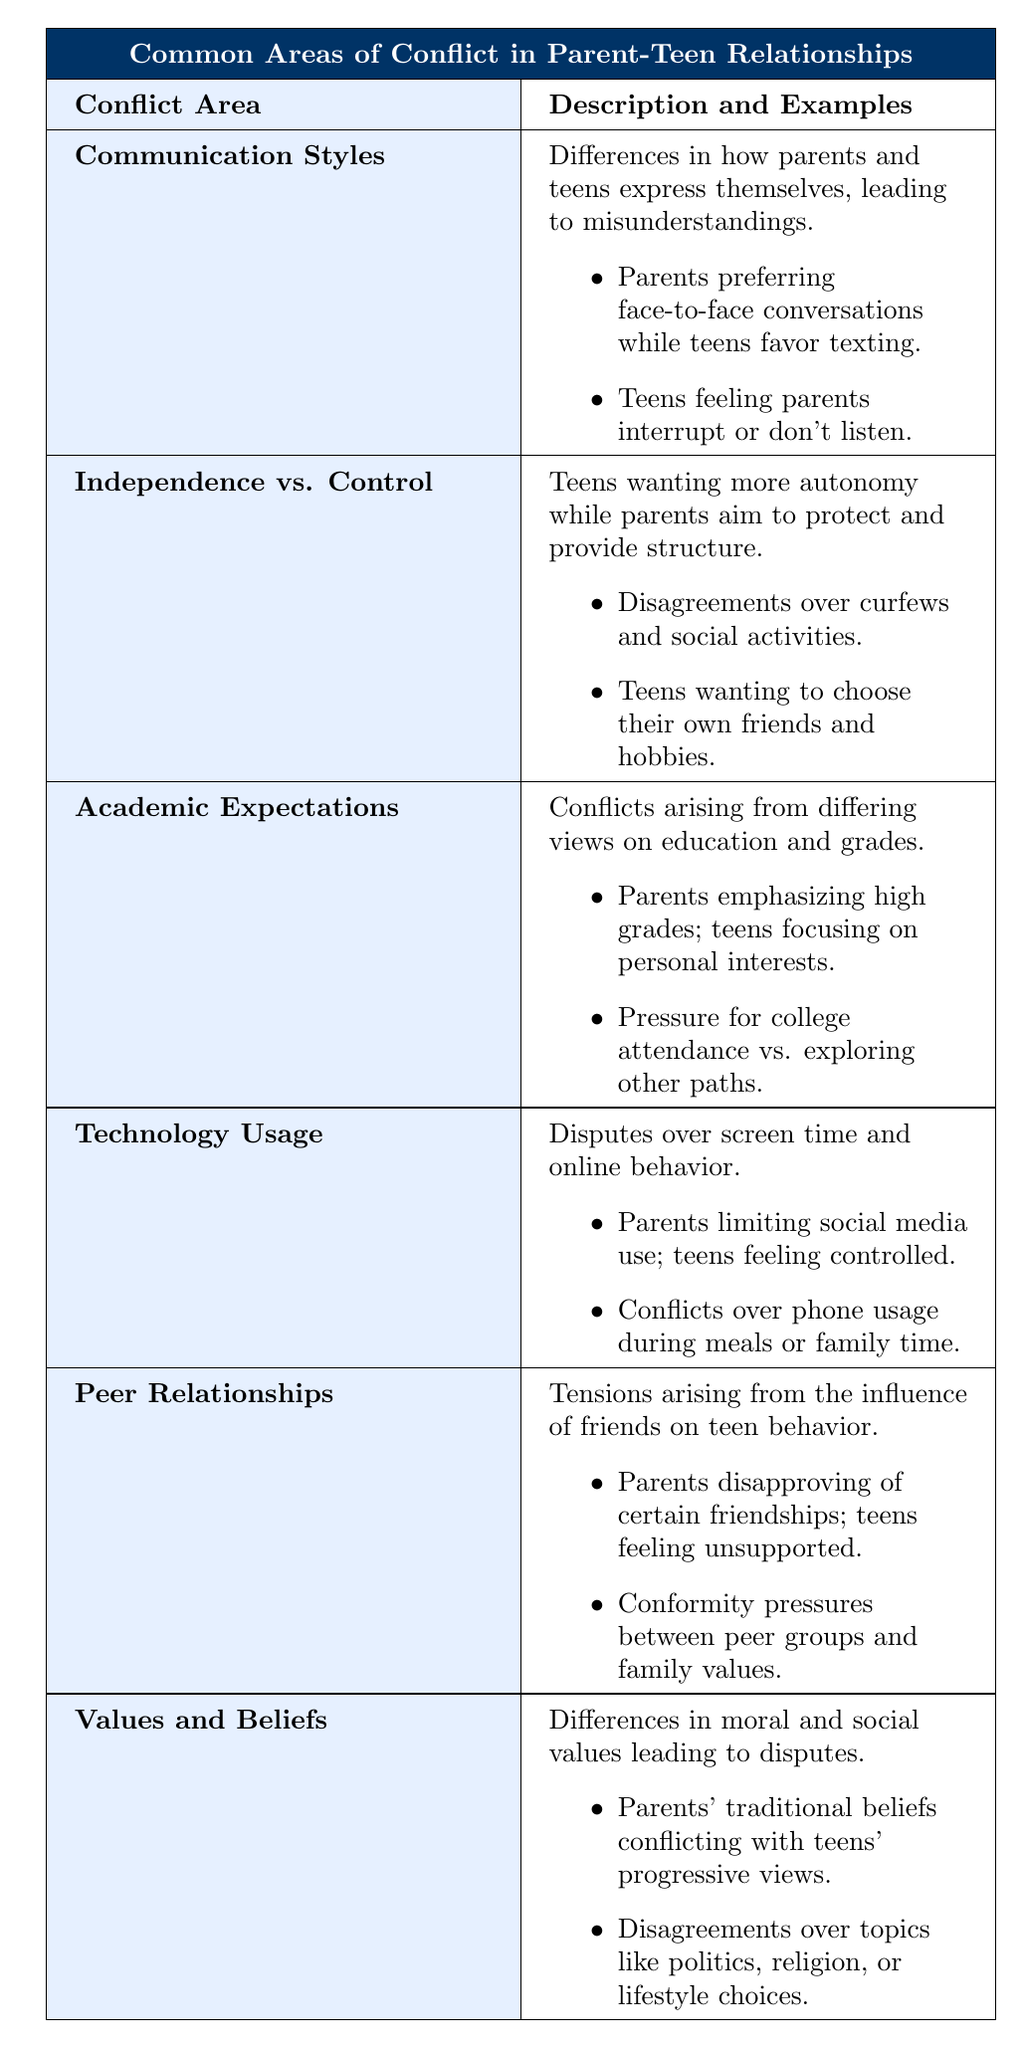What is one example of a disagreement in the "Independence vs. Control" conflict area? The table mentions that disagreements over curfews and social activities are a common example in this conflict area.
Answer: Disagreements over curfews and social activities What is the primary issue in the "Communication Styles" conflict area? The description states that the primary issue arises from differences in how parents and teens express themselves, leading to misunderstandings.
Answer: Differences in expression leading to misunderstandings Is "Technology Usage" one of the conflict areas listed? The table explicitly lists "Technology Usage" as one of the conflict areas, confirming its presence.
Answer: Yes What are parents' expectations regarding academics according to the table? The table indicates that parents emphasize high grades in the "Academic Expectations" conflict area.
Answer: Parents emphasize high grades What is the relationship between peer approval and tension in the "Peer Relationships" conflict area? The table shows that tensions arise when parents disapprove of certain friendships, contributing to feelings of being unsupported among teens.
Answer: Disapproval leads to feelings of being unsupported How many conflict areas focus on communication issues? The table highlights two areas that focus on communication: "Communication Styles" and "Peer Relationships" (indirectly addressing communication with peers). Totaling them gives two areas.
Answer: Two areas Are "Values and Beliefs" conflicts likely to occur between parents and teens? The table states that differences in moral and social values often lead to disputes, indicating that such conflicts are likely.
Answer: Yes What is the difference in focus between parents and teens in the "Academic Expectations" area? Parents focus on high grades, whereas teens are more concerned with personal interests, indicating a divergence in focus.
Answer: Parents focus on grades; teens on interests Which conflict area mentions issues related to screen time? "Technology Usage" is the conflict area that discusses disputes over screen time and online behavior.
Answer: Technology Usage Summarize the main tension in "Values and Beliefs." The main tension arises from parents' traditional beliefs conflicting with teens' progressive views, leading to disputes over various topics.
Answer: Traditional vs. progressive beliefs 